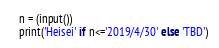<code> <loc_0><loc_0><loc_500><loc_500><_Python_>n = (input())
print('Heisei' if n<='2019/4/30' else 'TBD')</code> 